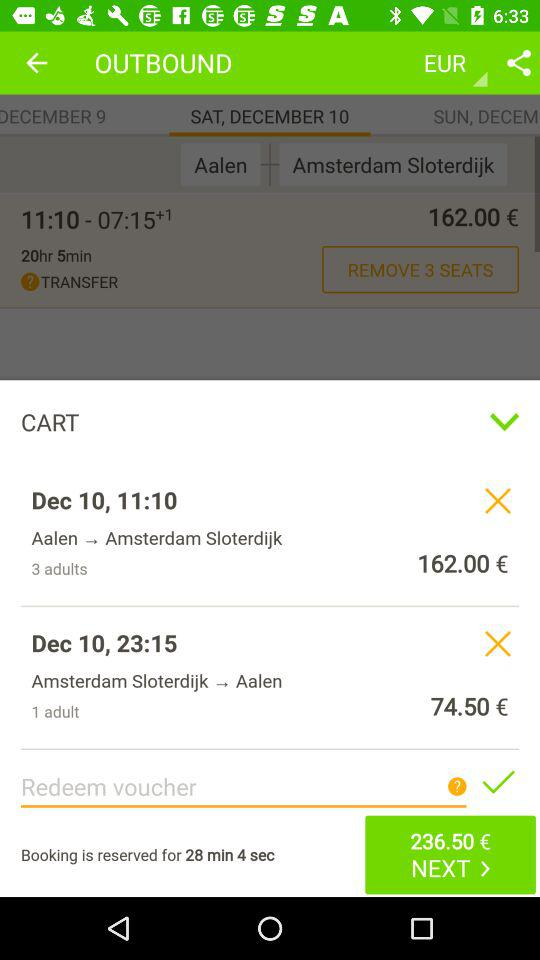What date is displayed on the screen for Amsterdam Sloterdijk to Aalen? The displayed date is December 10. 